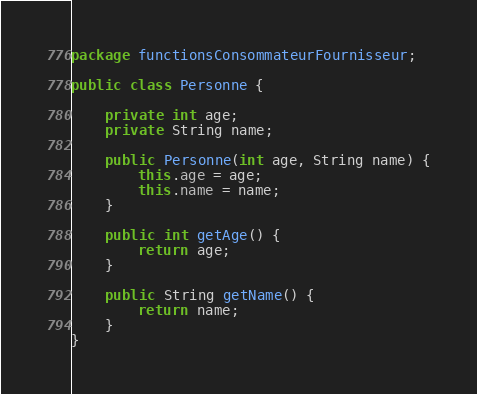<code> <loc_0><loc_0><loc_500><loc_500><_Java_>package functionsConsommateurFournisseur;

public class Personne {

    private int age;
    private String name;

    public Personne(int age, String name) {
        this.age = age;
        this.name = name;
    }

    public int getAge() {
        return age;
    }

    public String getName() {
        return name;
    }
}
</code> 